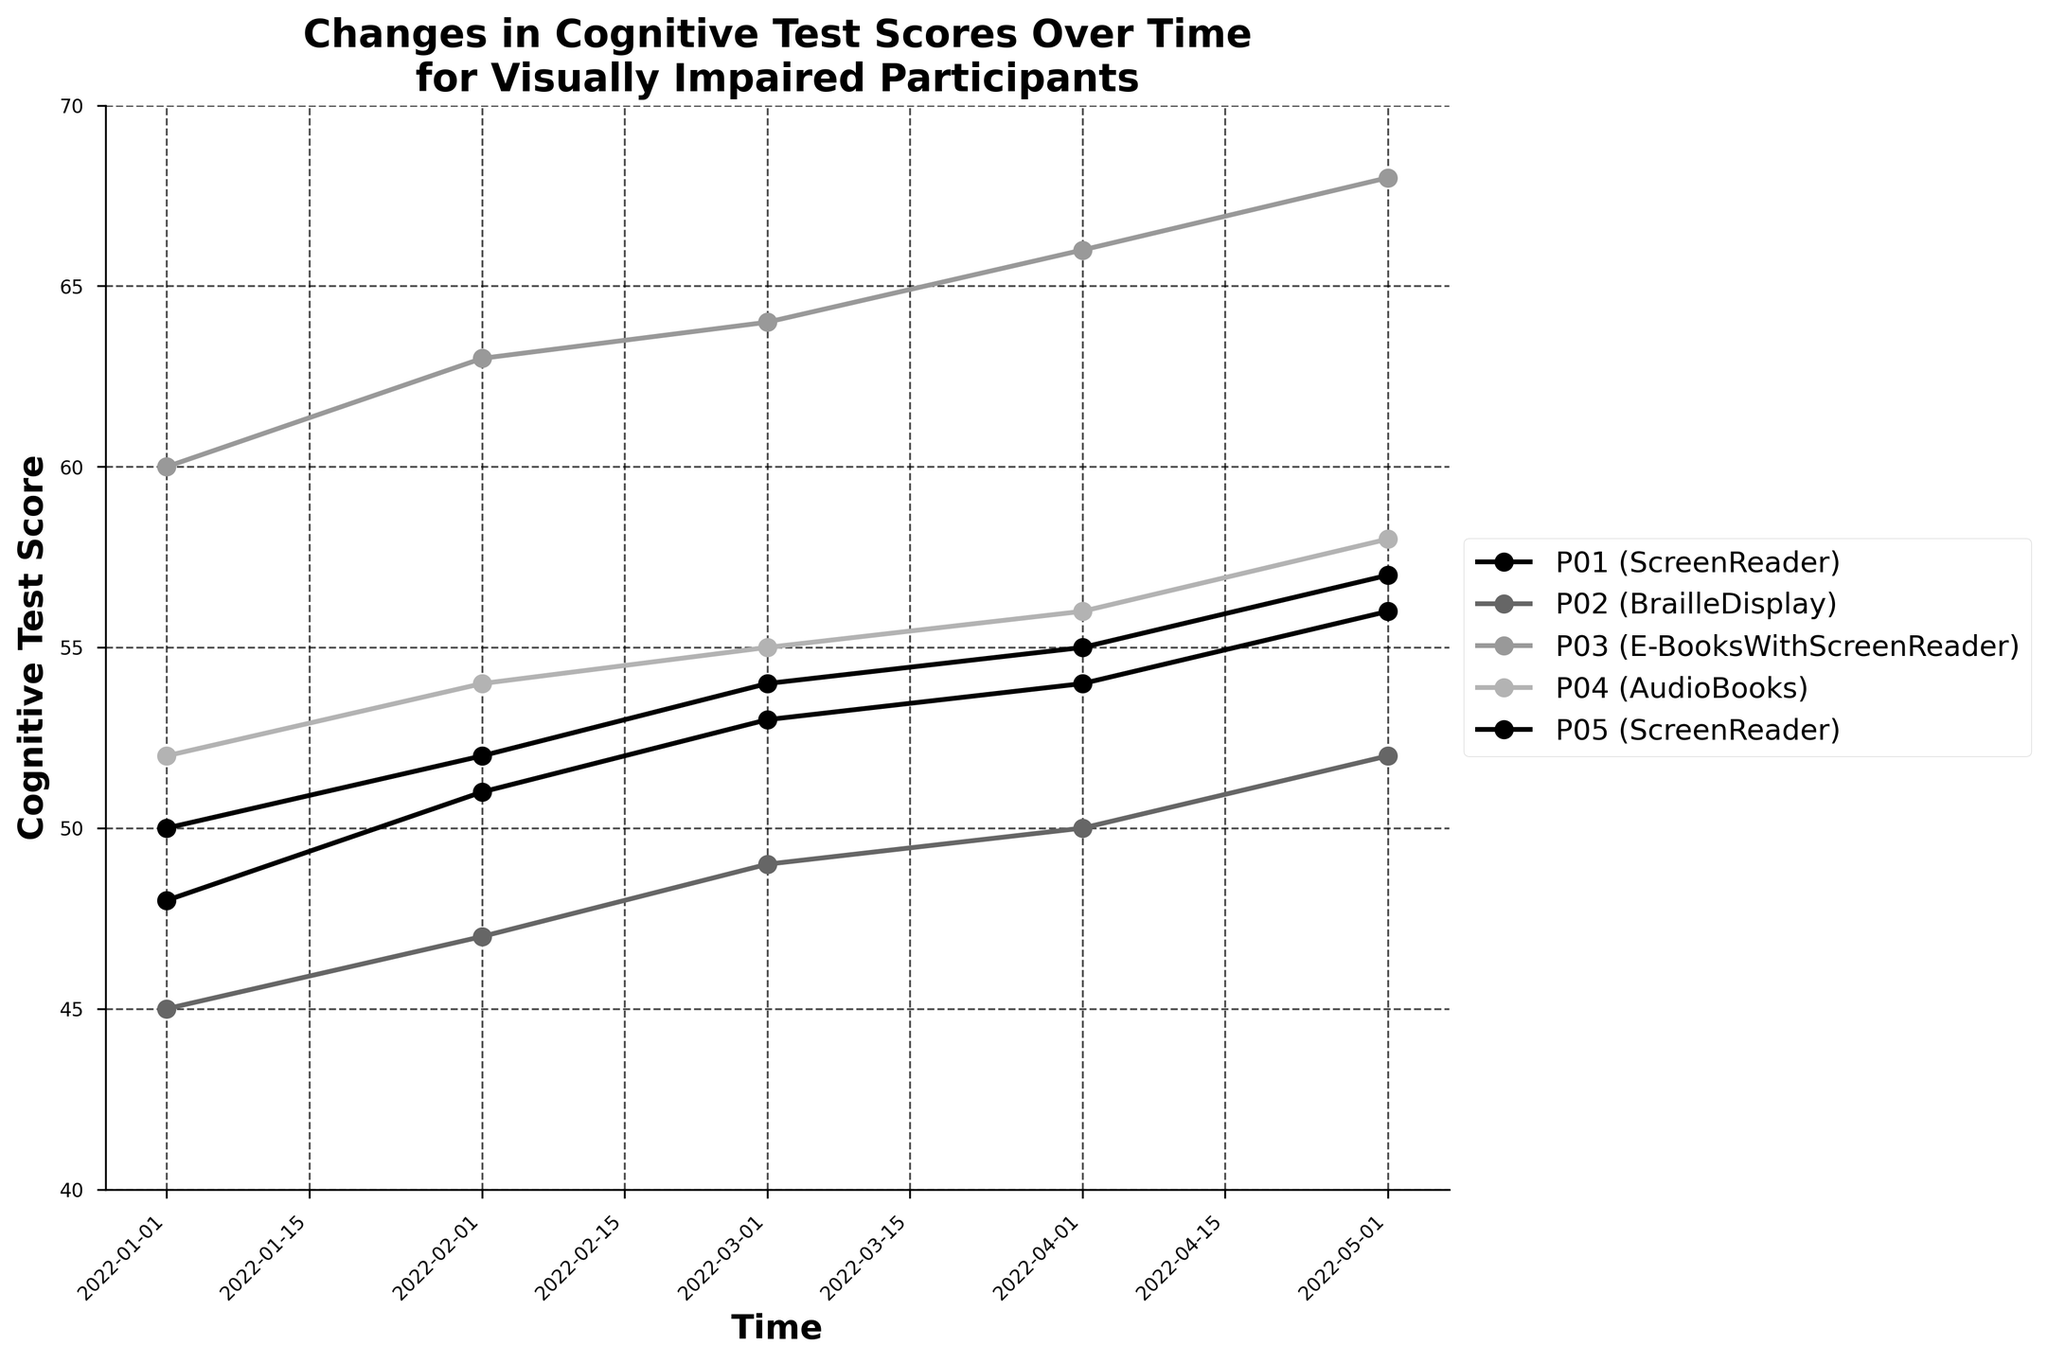What is the y-axis measuring? The y-axis of this time series plot measures the "Cognitive Test Score" of the participants over time.
Answer: Cognitive Test Score Which participant shows the highest cognitive test score in the final month? Participant P03, using E-Books With Screen Reader, shows the highest cognitive test score of 68 in May 2022, which is the final month in the dataset.
Answer: P03 How many different reading solutions are being compared in the figure? The plot compares four distinct reading solutions: Screen Reader, Braille Display, E-Books With Screen Reader, and Audio Books, as indicated by the legend.
Answer: 4 What is the difference in cognitive test scores between Participants P01 and P05 in the first month? In the first month (January 2022), Participant P01 has a cognitive test score of 50, and Participant P05 has a score of 48. The difference between them is 50 - 48 = 2 points.
Answer: 2 Which participant shows the most consistent improvement over time in their cognitive test scores? Participant P03 shows the most consistent improvement over time, increasing their cognitive test score every month from January (60) to May (68).
Answer: P03 For how many months do we have data on cognitive test scores? The time axis shows data points from January 2022 to May 2022, so we have data for 5 months.
Answer: 5 What is the average increase in cognitive test scores for Participant P02 over the recorded period? Participant P02's scores over the months are: 45, 47, 49, 50, 52. The average increase per month is calculated by ((47 - 45) + (49 - 47) + (50 - 49) + (52 - 50))/4 = 2/4 = 2 points per month.
Answer: 2 What is the highest cognitive test score achieved and by which participant? The highest cognitive test score achieved is 68 by Participant P03 using E-Books With Screen Reader in May 2022.
Answer: 68 by P03 Comparing Participants P01 and P04, who shows greater improvement in cognitive test scores from the first to the last month? By how much? Participant P01 improves from 50 to 57 (a 7-point increase), while Participant P04 improves from 52 to 58 (a 6-point increase). Therefore, P01 shows a greater improvement by 1 point (7 - 6).
Answer: P01 by 1 point Which participant using Screen Reader has the highest test score at any point in time? Among the participants using Screen Reader, Participant P01 achieves the highest test score of 57 points in May 2022.
Answer: P01 